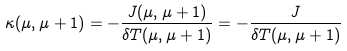Convert formula to latex. <formula><loc_0><loc_0><loc_500><loc_500>\kappa ( \mu , \mu + 1 ) = - \frac { J ( \mu , \mu + 1 ) } { \delta T ( \mu , \mu + 1 ) } = - \frac { J } { \delta T ( \mu , \mu + 1 ) }</formula> 